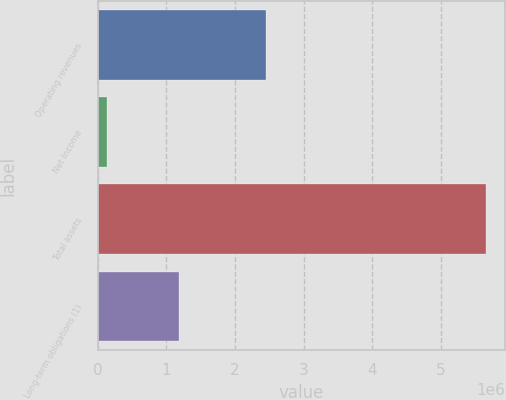Convert chart to OTSL. <chart><loc_0><loc_0><loc_500><loc_500><bar_chart><fcel>Operating revenues<fcel>Net Income<fcel>Total assets<fcel>Long-term obligations (1)<nl><fcel>2.45126e+06<fcel>137618<fcel>5.65484e+06<fcel>1.19104e+06<nl></chart> 